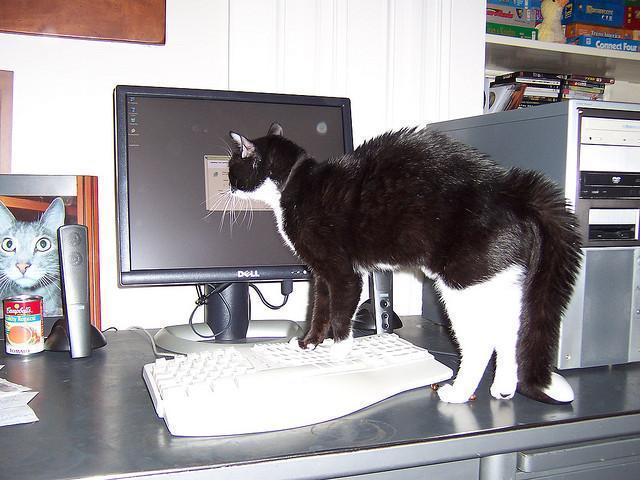How many books are in the photo?
Give a very brief answer. 2. 